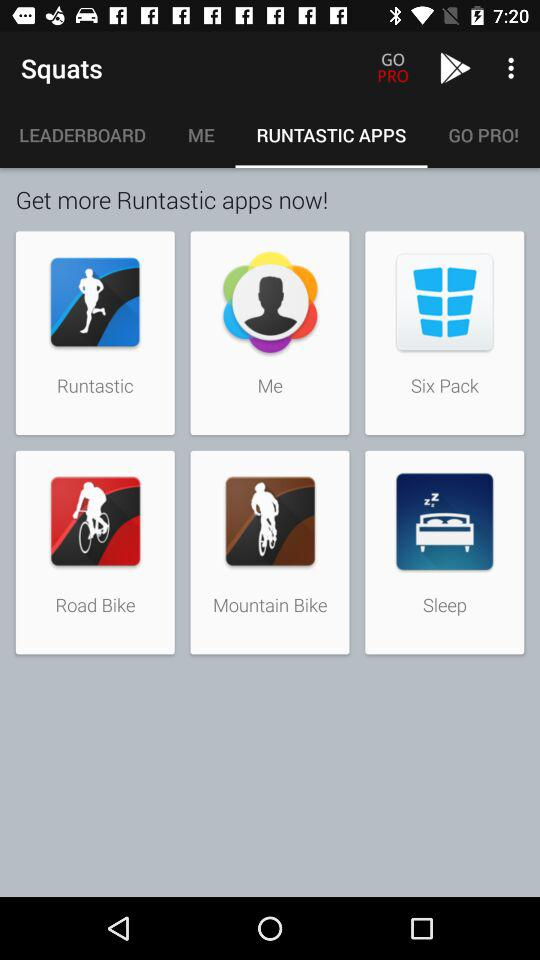Which tab is selected? The selected tab is "RUNTASTIC APPS". 